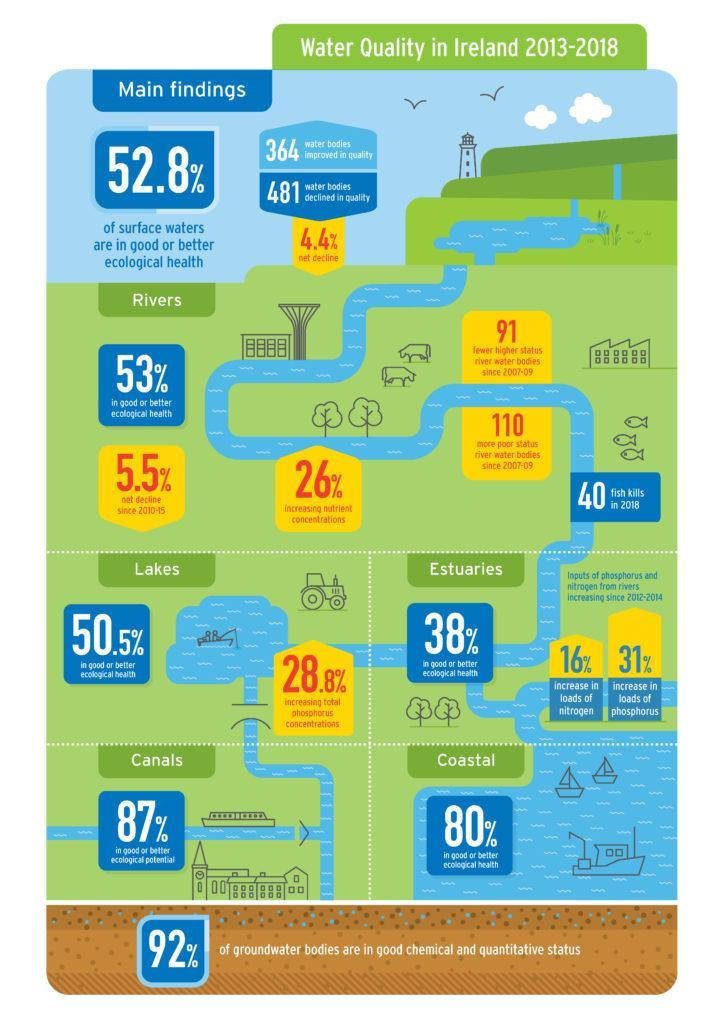What percentage of lakes in Ireland are not in good or better ecological health in 2013-18?
Answer the question with a short phrase. 49.5% What is the percentage of increasing nutrient concentrations in rivers of Ireland in 2013-18? 26% What percentage of canals are not in good or better ecological potential in Ireland in 2013-18? 13% What is the net decline in the quality of waterbodies in Ireland in 2013-18? 4.4% What is the percentage increase in loads of phosphorous in Estuaries of Ireland in 2013-18? 31% What percentage of ground water bodies are not in good chemical & quantitative status in Ireland in 2013-18? 8% 